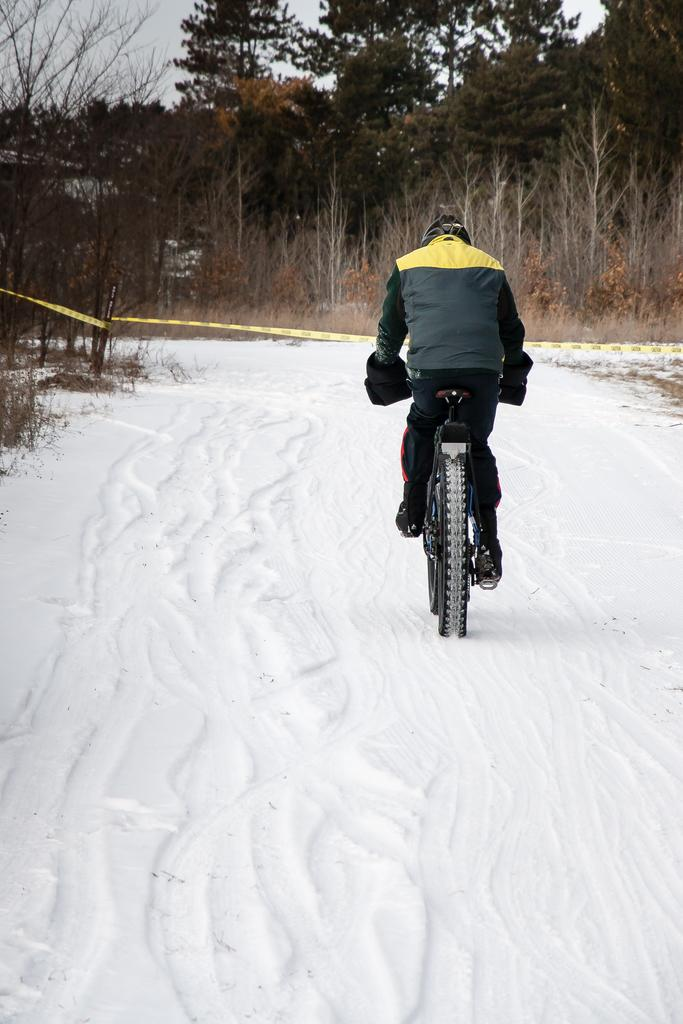What is covering the ground in the image? There is snow on the ground in the image. What activity is the person in the image engaged in? There is a person riding a bicycle in the image. What type of natural vegetation can be seen in the image? There are trees in the image. What is visible at the top of the image? The sky is visible at the top of the image. How many spiders are crawling on the person riding the bicycle in the image? There are no spiders visible in the image; it features a person riding a bicycle in the snow. What advice might the father in the image give to the person riding the bicycle? There is no father present in the image, so it is not possible to determine what advice might be given. 